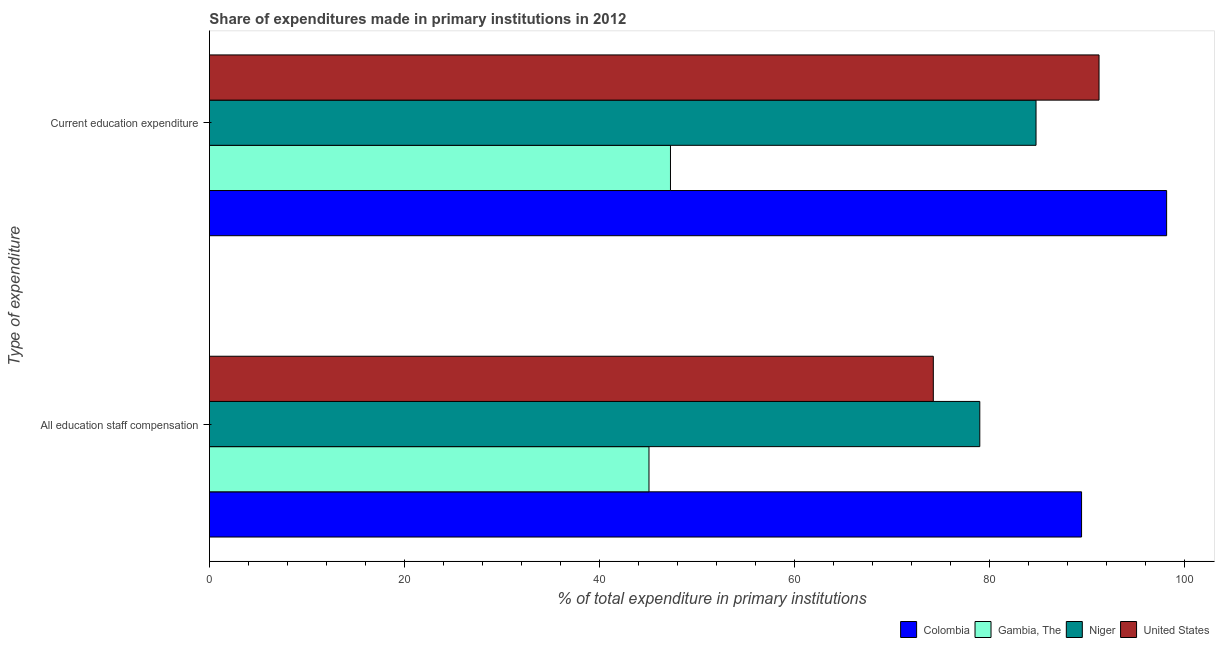How many different coloured bars are there?
Keep it short and to the point. 4. Are the number of bars on each tick of the Y-axis equal?
Provide a succinct answer. Yes. What is the label of the 1st group of bars from the top?
Give a very brief answer. Current education expenditure. What is the expenditure in staff compensation in Gambia, The?
Your answer should be compact. 45.06. Across all countries, what is the maximum expenditure in staff compensation?
Give a very brief answer. 89.4. Across all countries, what is the minimum expenditure in education?
Offer a terse response. 47.26. In which country was the expenditure in education maximum?
Offer a very short reply. Colombia. In which country was the expenditure in education minimum?
Your answer should be very brief. Gambia, The. What is the total expenditure in staff compensation in the graph?
Make the answer very short. 287.63. What is the difference between the expenditure in education in Niger and that in Colombia?
Your answer should be very brief. -13.39. What is the difference between the expenditure in education in Colombia and the expenditure in staff compensation in United States?
Your answer should be compact. 23.92. What is the average expenditure in education per country?
Your response must be concise. 80.33. What is the difference between the expenditure in education and expenditure in staff compensation in Niger?
Give a very brief answer. 5.76. What is the ratio of the expenditure in education in Gambia, The to that in Niger?
Offer a terse response. 0.56. Is the expenditure in education in Niger less than that in Colombia?
Your answer should be compact. Yes. What does the 2nd bar from the top in All education staff compensation represents?
Your answer should be compact. Niger. What does the 2nd bar from the bottom in All education staff compensation represents?
Offer a terse response. Gambia, The. Are all the bars in the graph horizontal?
Ensure brevity in your answer.  Yes. Are the values on the major ticks of X-axis written in scientific E-notation?
Offer a very short reply. No. What is the title of the graph?
Your answer should be very brief. Share of expenditures made in primary institutions in 2012. Does "Jamaica" appear as one of the legend labels in the graph?
Keep it short and to the point. No. What is the label or title of the X-axis?
Your answer should be compact. % of total expenditure in primary institutions. What is the label or title of the Y-axis?
Make the answer very short. Type of expenditure. What is the % of total expenditure in primary institutions of Colombia in All education staff compensation?
Keep it short and to the point. 89.4. What is the % of total expenditure in primary institutions of Gambia, The in All education staff compensation?
Ensure brevity in your answer.  45.06. What is the % of total expenditure in primary institutions in Niger in All education staff compensation?
Provide a short and direct response. 78.97. What is the % of total expenditure in primary institutions in United States in All education staff compensation?
Offer a very short reply. 74.2. What is the % of total expenditure in primary institutions in Colombia in Current education expenditure?
Your answer should be compact. 98.12. What is the % of total expenditure in primary institutions of Gambia, The in Current education expenditure?
Offer a terse response. 47.26. What is the % of total expenditure in primary institutions in Niger in Current education expenditure?
Your answer should be compact. 84.73. What is the % of total expenditure in primary institutions in United States in Current education expenditure?
Give a very brief answer. 91.19. Across all Type of expenditure, what is the maximum % of total expenditure in primary institutions in Colombia?
Offer a very short reply. 98.12. Across all Type of expenditure, what is the maximum % of total expenditure in primary institutions in Gambia, The?
Ensure brevity in your answer.  47.26. Across all Type of expenditure, what is the maximum % of total expenditure in primary institutions in Niger?
Ensure brevity in your answer.  84.73. Across all Type of expenditure, what is the maximum % of total expenditure in primary institutions in United States?
Provide a succinct answer. 91.19. Across all Type of expenditure, what is the minimum % of total expenditure in primary institutions of Colombia?
Provide a succinct answer. 89.4. Across all Type of expenditure, what is the minimum % of total expenditure in primary institutions of Gambia, The?
Your answer should be very brief. 45.06. Across all Type of expenditure, what is the minimum % of total expenditure in primary institutions in Niger?
Your answer should be compact. 78.97. Across all Type of expenditure, what is the minimum % of total expenditure in primary institutions in United States?
Give a very brief answer. 74.2. What is the total % of total expenditure in primary institutions in Colombia in the graph?
Make the answer very short. 187.52. What is the total % of total expenditure in primary institutions in Gambia, The in the graph?
Your answer should be very brief. 92.32. What is the total % of total expenditure in primary institutions in Niger in the graph?
Your answer should be very brief. 163.7. What is the total % of total expenditure in primary institutions in United States in the graph?
Your answer should be very brief. 165.39. What is the difference between the % of total expenditure in primary institutions in Colombia in All education staff compensation and that in Current education expenditure?
Give a very brief answer. -8.72. What is the difference between the % of total expenditure in primary institutions in Gambia, The in All education staff compensation and that in Current education expenditure?
Give a very brief answer. -2.2. What is the difference between the % of total expenditure in primary institutions of Niger in All education staff compensation and that in Current education expenditure?
Make the answer very short. -5.76. What is the difference between the % of total expenditure in primary institutions of United States in All education staff compensation and that in Current education expenditure?
Your answer should be compact. -16.99. What is the difference between the % of total expenditure in primary institutions in Colombia in All education staff compensation and the % of total expenditure in primary institutions in Gambia, The in Current education expenditure?
Ensure brevity in your answer.  42.14. What is the difference between the % of total expenditure in primary institutions of Colombia in All education staff compensation and the % of total expenditure in primary institutions of Niger in Current education expenditure?
Provide a short and direct response. 4.67. What is the difference between the % of total expenditure in primary institutions of Colombia in All education staff compensation and the % of total expenditure in primary institutions of United States in Current education expenditure?
Give a very brief answer. -1.79. What is the difference between the % of total expenditure in primary institutions in Gambia, The in All education staff compensation and the % of total expenditure in primary institutions in Niger in Current education expenditure?
Provide a succinct answer. -39.67. What is the difference between the % of total expenditure in primary institutions in Gambia, The in All education staff compensation and the % of total expenditure in primary institutions in United States in Current education expenditure?
Your answer should be compact. -46.13. What is the difference between the % of total expenditure in primary institutions of Niger in All education staff compensation and the % of total expenditure in primary institutions of United States in Current education expenditure?
Give a very brief answer. -12.22. What is the average % of total expenditure in primary institutions of Colombia per Type of expenditure?
Offer a terse response. 93.76. What is the average % of total expenditure in primary institutions of Gambia, The per Type of expenditure?
Provide a short and direct response. 46.16. What is the average % of total expenditure in primary institutions of Niger per Type of expenditure?
Your answer should be compact. 81.85. What is the average % of total expenditure in primary institutions in United States per Type of expenditure?
Offer a terse response. 82.7. What is the difference between the % of total expenditure in primary institutions of Colombia and % of total expenditure in primary institutions of Gambia, The in All education staff compensation?
Your response must be concise. 44.34. What is the difference between the % of total expenditure in primary institutions of Colombia and % of total expenditure in primary institutions of Niger in All education staff compensation?
Give a very brief answer. 10.43. What is the difference between the % of total expenditure in primary institutions of Colombia and % of total expenditure in primary institutions of United States in All education staff compensation?
Your answer should be very brief. 15.2. What is the difference between the % of total expenditure in primary institutions in Gambia, The and % of total expenditure in primary institutions in Niger in All education staff compensation?
Give a very brief answer. -33.91. What is the difference between the % of total expenditure in primary institutions in Gambia, The and % of total expenditure in primary institutions in United States in All education staff compensation?
Offer a terse response. -29.15. What is the difference between the % of total expenditure in primary institutions of Niger and % of total expenditure in primary institutions of United States in All education staff compensation?
Offer a very short reply. 4.76. What is the difference between the % of total expenditure in primary institutions of Colombia and % of total expenditure in primary institutions of Gambia, The in Current education expenditure?
Make the answer very short. 50.86. What is the difference between the % of total expenditure in primary institutions of Colombia and % of total expenditure in primary institutions of Niger in Current education expenditure?
Make the answer very short. 13.39. What is the difference between the % of total expenditure in primary institutions of Colombia and % of total expenditure in primary institutions of United States in Current education expenditure?
Offer a very short reply. 6.93. What is the difference between the % of total expenditure in primary institutions in Gambia, The and % of total expenditure in primary institutions in Niger in Current education expenditure?
Offer a very short reply. -37.47. What is the difference between the % of total expenditure in primary institutions in Gambia, The and % of total expenditure in primary institutions in United States in Current education expenditure?
Provide a short and direct response. -43.93. What is the difference between the % of total expenditure in primary institutions in Niger and % of total expenditure in primary institutions in United States in Current education expenditure?
Provide a short and direct response. -6.46. What is the ratio of the % of total expenditure in primary institutions in Colombia in All education staff compensation to that in Current education expenditure?
Give a very brief answer. 0.91. What is the ratio of the % of total expenditure in primary institutions in Gambia, The in All education staff compensation to that in Current education expenditure?
Give a very brief answer. 0.95. What is the ratio of the % of total expenditure in primary institutions in Niger in All education staff compensation to that in Current education expenditure?
Keep it short and to the point. 0.93. What is the ratio of the % of total expenditure in primary institutions of United States in All education staff compensation to that in Current education expenditure?
Your answer should be compact. 0.81. What is the difference between the highest and the second highest % of total expenditure in primary institutions of Colombia?
Your answer should be very brief. 8.72. What is the difference between the highest and the second highest % of total expenditure in primary institutions of Gambia, The?
Provide a succinct answer. 2.2. What is the difference between the highest and the second highest % of total expenditure in primary institutions in Niger?
Offer a very short reply. 5.76. What is the difference between the highest and the second highest % of total expenditure in primary institutions of United States?
Ensure brevity in your answer.  16.99. What is the difference between the highest and the lowest % of total expenditure in primary institutions of Colombia?
Keep it short and to the point. 8.72. What is the difference between the highest and the lowest % of total expenditure in primary institutions in Gambia, The?
Your answer should be very brief. 2.2. What is the difference between the highest and the lowest % of total expenditure in primary institutions in Niger?
Offer a very short reply. 5.76. What is the difference between the highest and the lowest % of total expenditure in primary institutions of United States?
Keep it short and to the point. 16.99. 